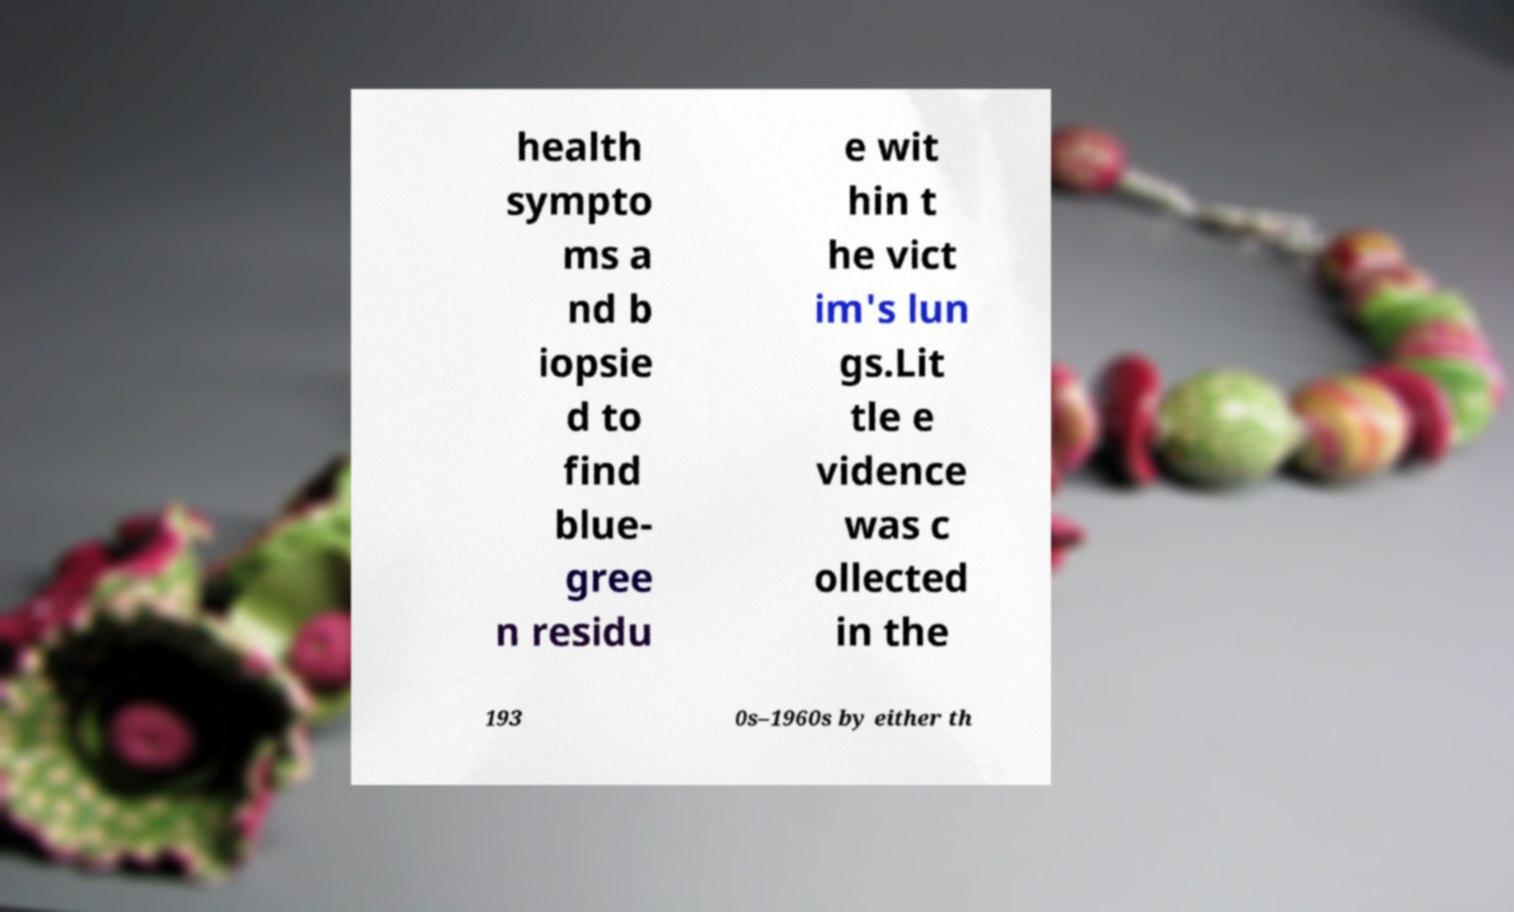There's text embedded in this image that I need extracted. Can you transcribe it verbatim? health sympto ms a nd b iopsie d to find blue- gree n residu e wit hin t he vict im's lun gs.Lit tle e vidence was c ollected in the 193 0s–1960s by either th 